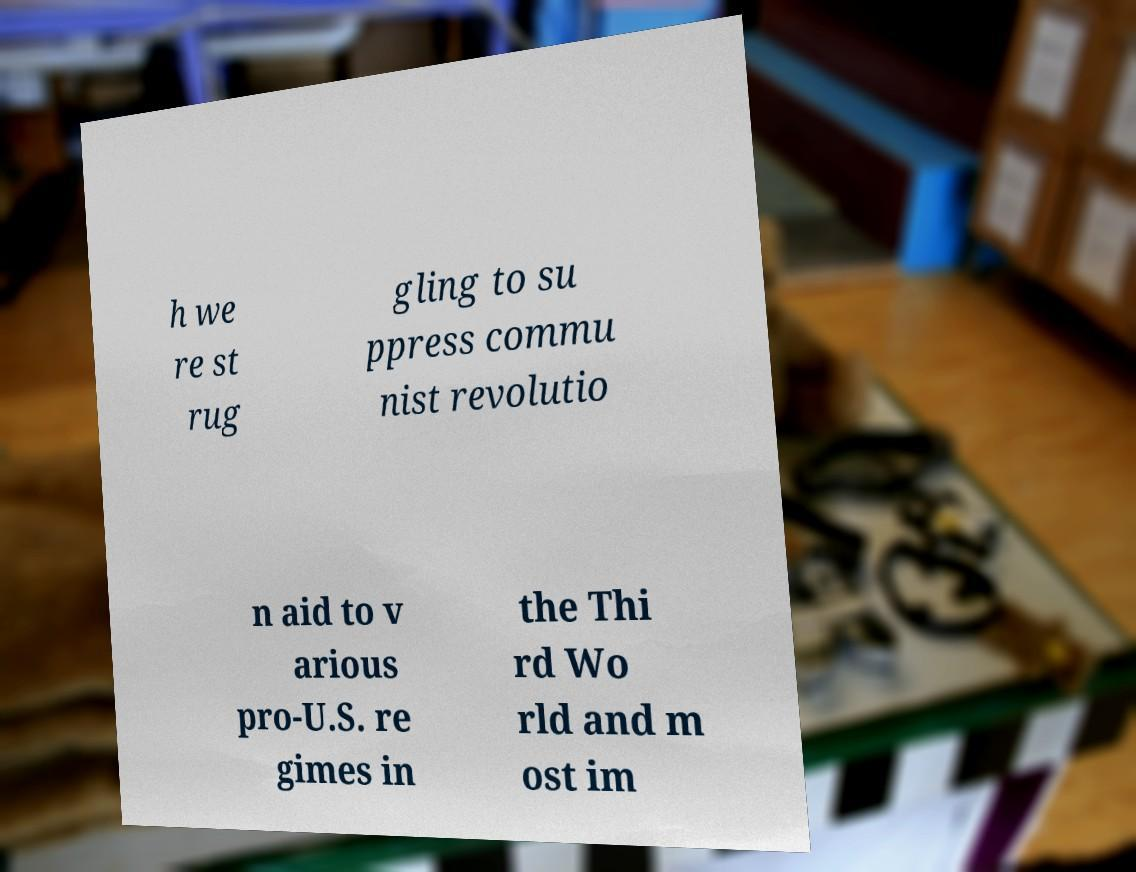There's text embedded in this image that I need extracted. Can you transcribe it verbatim? h we re st rug gling to su ppress commu nist revolutio n aid to v arious pro-U.S. re gimes in the Thi rd Wo rld and m ost im 